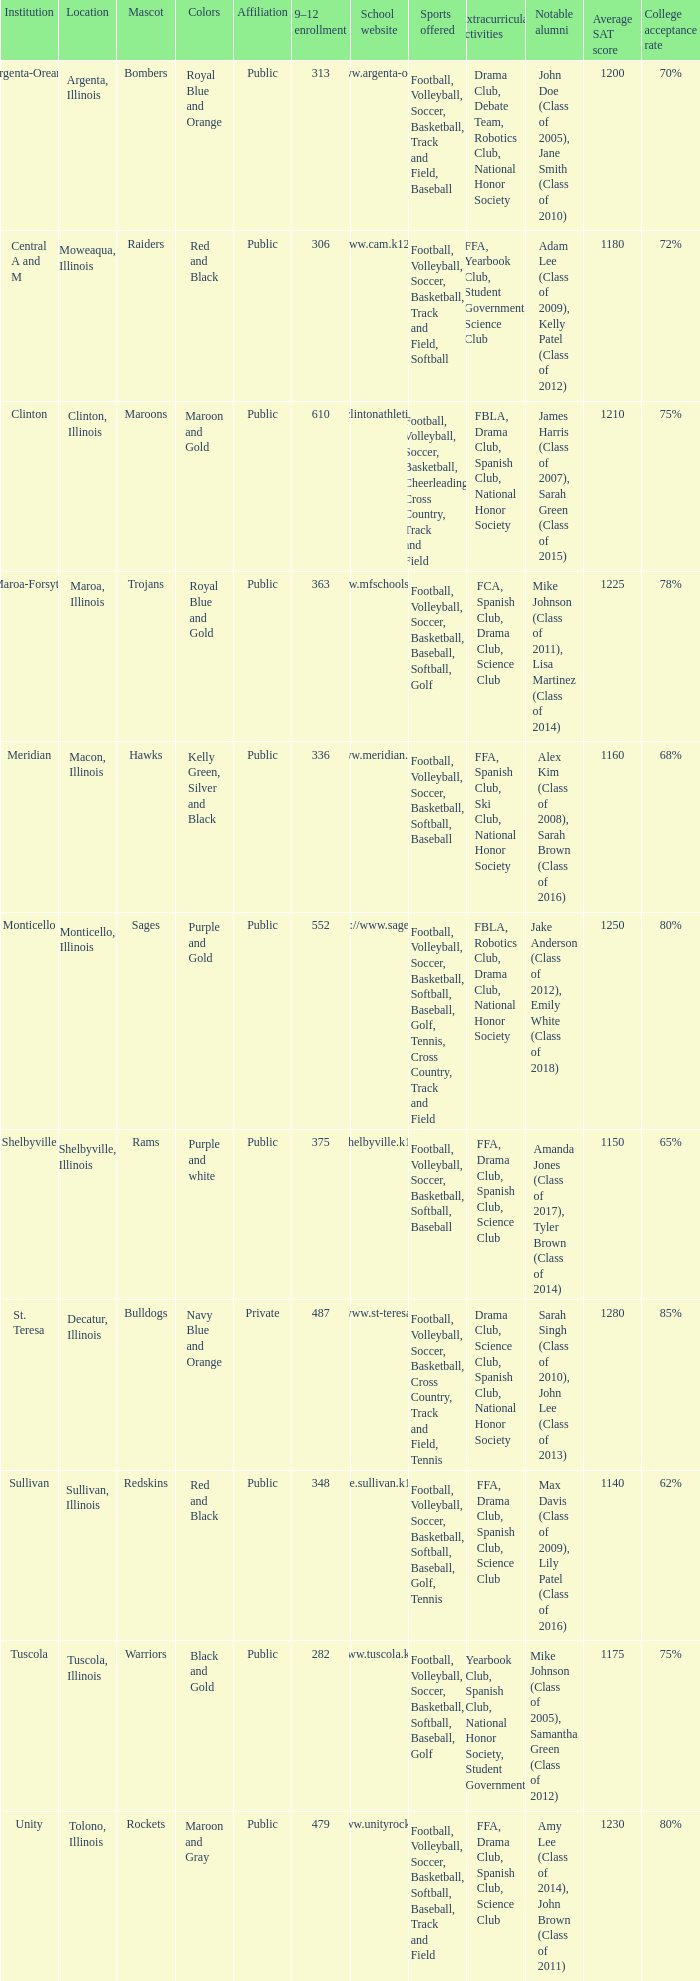What are the team colors from Tolono, Illinois? Maroon and Gray. 